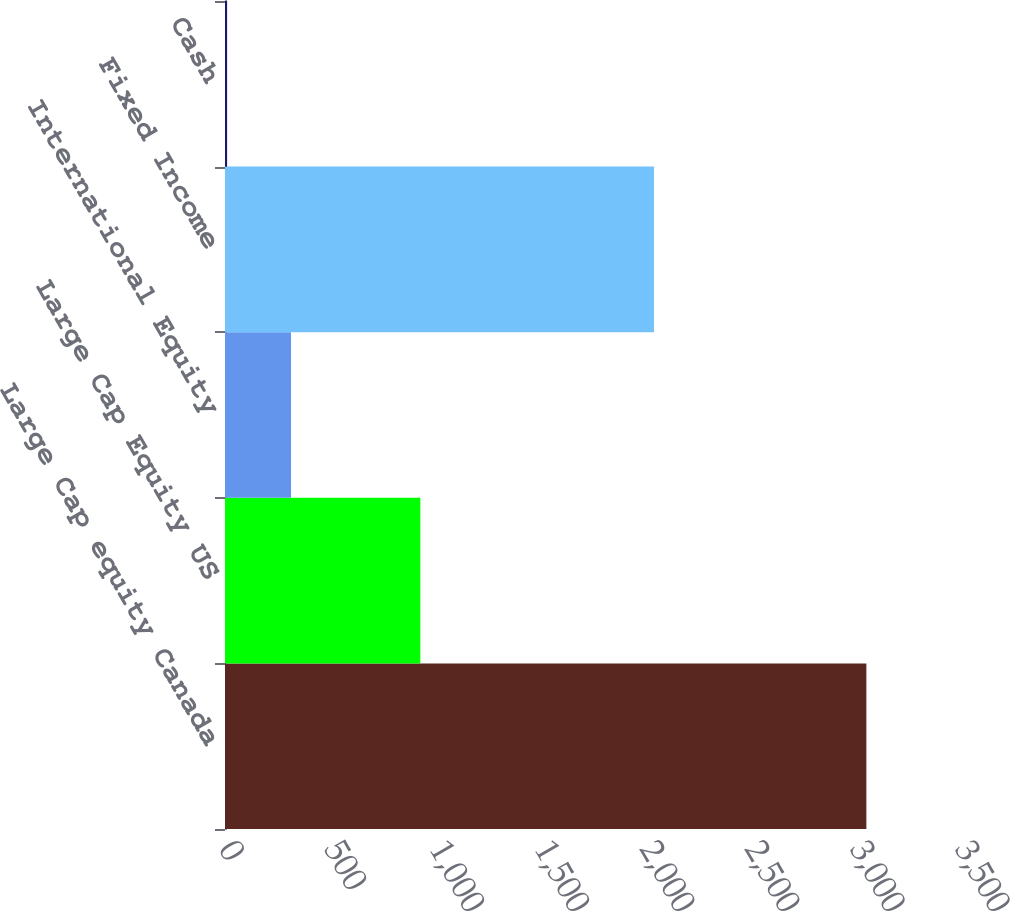Convert chart to OTSL. <chart><loc_0><loc_0><loc_500><loc_500><bar_chart><fcel>Large Cap equity Canada<fcel>Large Cap Equity US<fcel>International Equity<fcel>Fixed Income<fcel>Cash<nl><fcel>3050<fcel>929<fcel>314<fcel>2040<fcel>10<nl></chart> 